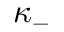<formula> <loc_0><loc_0><loc_500><loc_500>\kappa _ { - }</formula> 